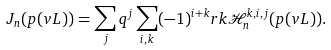<formula> <loc_0><loc_0><loc_500><loc_500>J _ { n } ( p ( v L ) ) = \sum _ { j } q ^ { j } \sum _ { i , k } ( - 1 ) ^ { i + k } { r k } \mathcal { H } _ { n } ^ { k , i , j } ( p ( v L ) ) .</formula> 